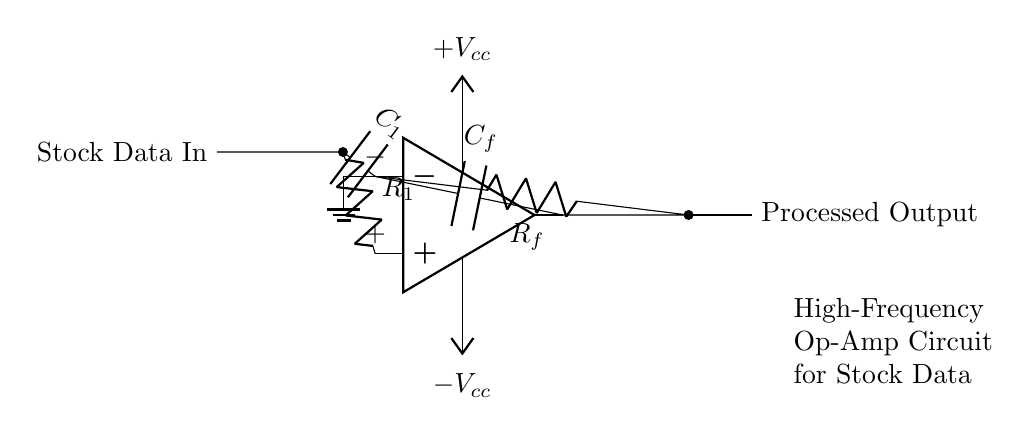What type of circuit is depicted? The circuit is a high-frequency operational amplifier circuit, as indicated by the presence of an op-amp symbol and the label "High-Frequency Op-Amp Circuit for Stock Data".
Answer: High-frequency operational amplifier circuit What component is used for input? The input component is a resistor labeled R1, which is connected to the operational amplifier's non-inverting input.
Answer: Resistor R1 What is the purpose of C1 in the circuit? C1 is a capacitor connected to the inverting input of the op-amp, which is typically used for coupling or filtering in signal processing applications.
Answer: Coupling or filtering What is the feedback resistor labeled as? The feedback resistor in the circuit is labeled Rf, which connects the output of the op-amp back to its inverting input to provide negative feedback.
Answer: Rf How is the operational amplifier powered? The operational amplifier is powered by a positive voltage Vcc and a negative voltage Vee, as shown by the connections in the circuit diagram.
Answer: Vcc and Vee What additional component is used for high-frequency compensation? The circuit includes a capacitor labeled Cf, which provides compensation to stabilize the amplifier at high frequencies.
Answer: Capacitor Cf What does the output represent? The output labeled "Processed Output" indicates that the circuit processes stock market data, providing the resulted information.
Answer: Processed Output 